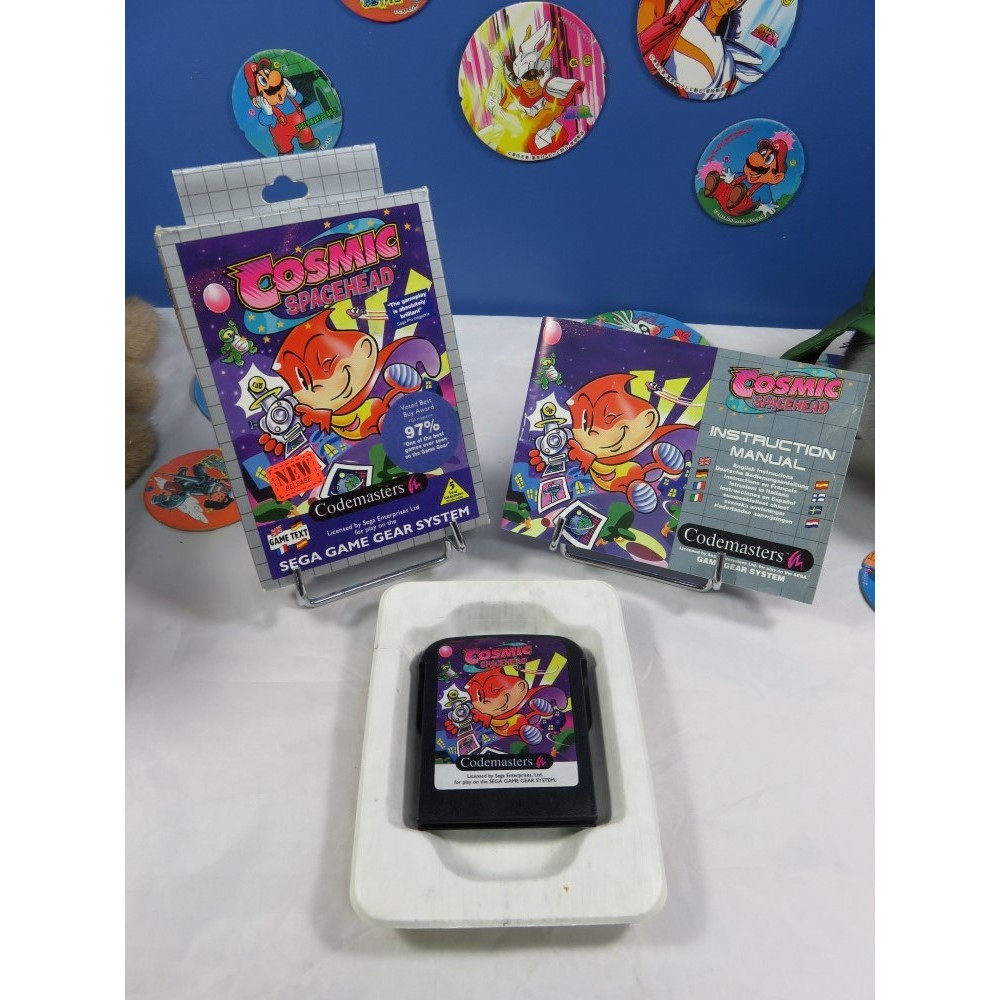Can you describe what the setting might be like in the game based on the promotional materials? Based on the promotional materials for 'Cosmic Spacehead', the setting of the game likely includes vibrant and whimsical outer space environments. The colorful and lively character design suggests a playful and adventurous atmosphere. The elements on the packaging, such as rocket ships and alien landscapes, hint at a world filled with varied intergalactic locations, from bustling spaceports to mysterious alien planets. The overall theme appears to be a light-hearted and fun-filled adventure through space, designed to captivate and entertain players of all ages. Why might the game developers include a high review score prominently on the packaging? Including a high review score prominently on the packaging serves several important purposes for the game developers. First, it acts as a powerful endorsement, signaling to potential buyers that the game is of high quality and well-received by critics. This can increase buyer confidence and make the product more attractive compared to other games. Secondly, it helps to differentiate the game in a crowded market, where consumers often look for quick indicators of quality. Finally, the review score can create a sense of urgency, suggesting that this is a highly regarded and potentially limited product, encouraging quicker purchasing decisions. 